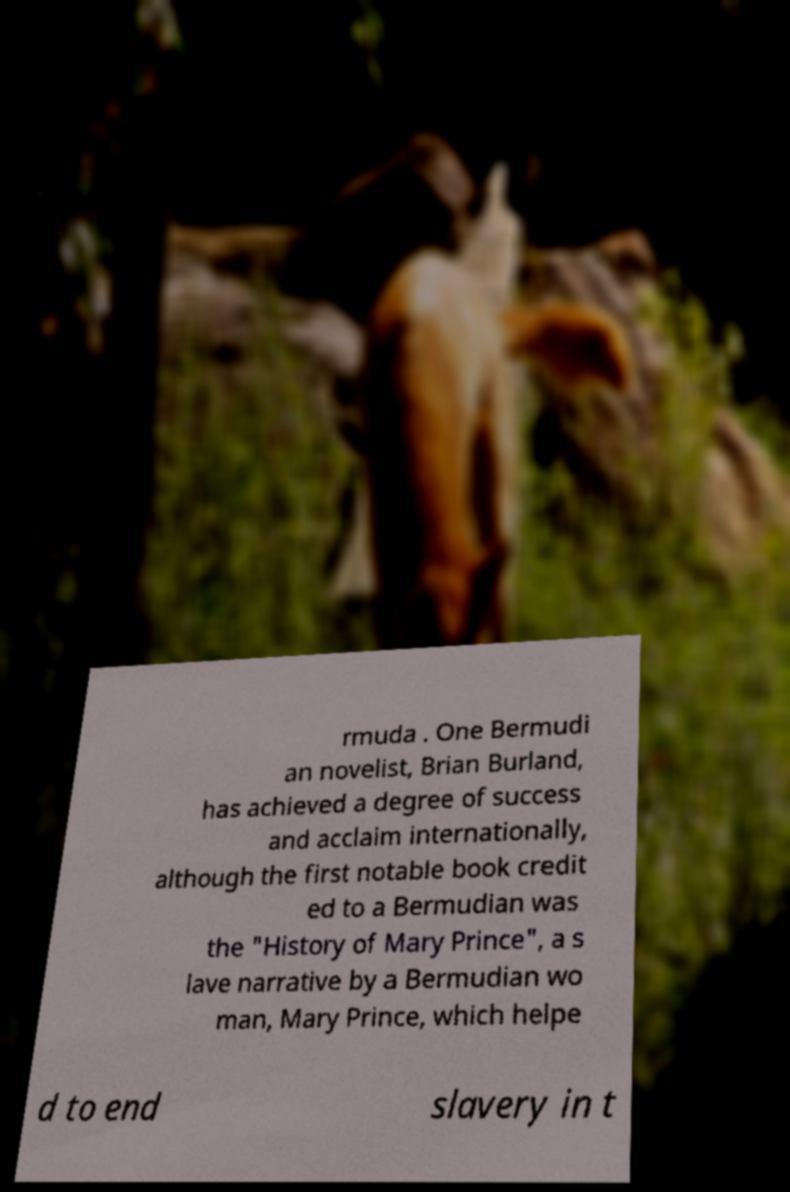Please identify and transcribe the text found in this image. rmuda . One Bermudi an novelist, Brian Burland, has achieved a degree of success and acclaim internationally, although the first notable book credit ed to a Bermudian was the "History of Mary Prince", a s lave narrative by a Bermudian wo man, Mary Prince, which helpe d to end slavery in t 